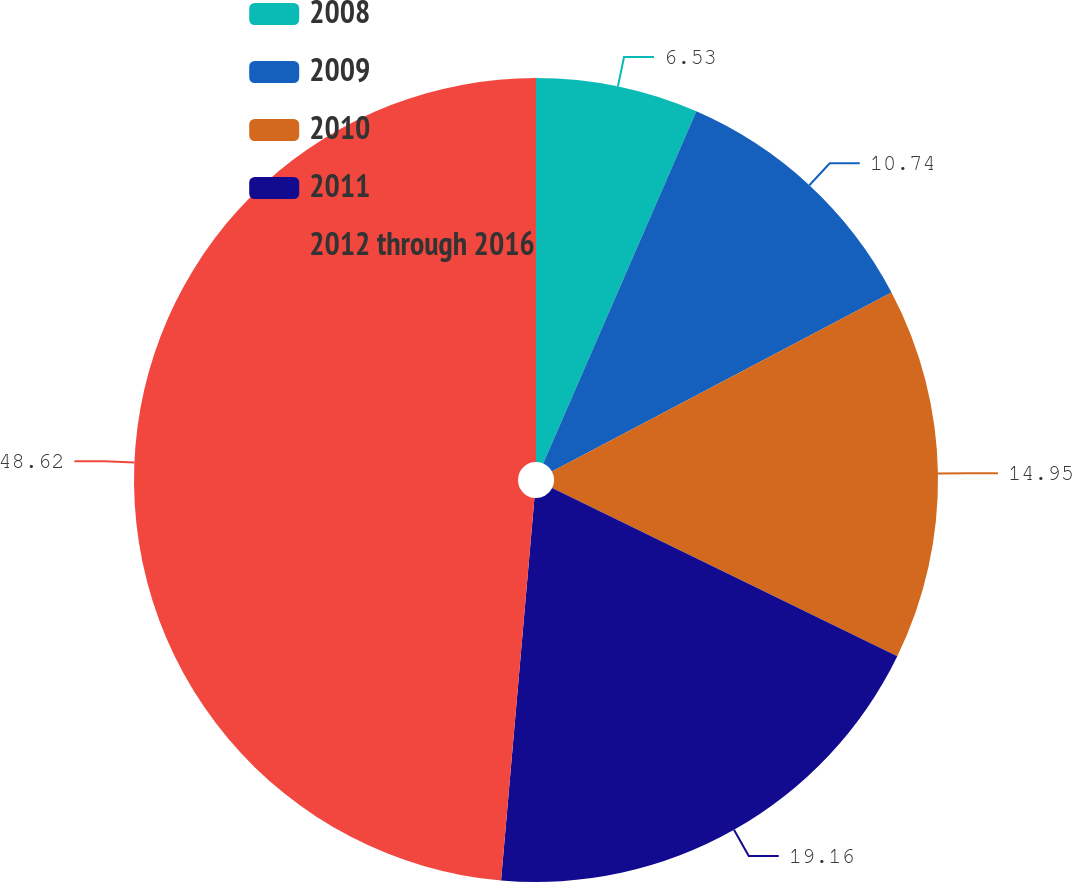Convert chart. <chart><loc_0><loc_0><loc_500><loc_500><pie_chart><fcel>2008<fcel>2009<fcel>2010<fcel>2011<fcel>2012 through 2016<nl><fcel>6.53%<fcel>10.74%<fcel>14.95%<fcel>19.16%<fcel>48.61%<nl></chart> 